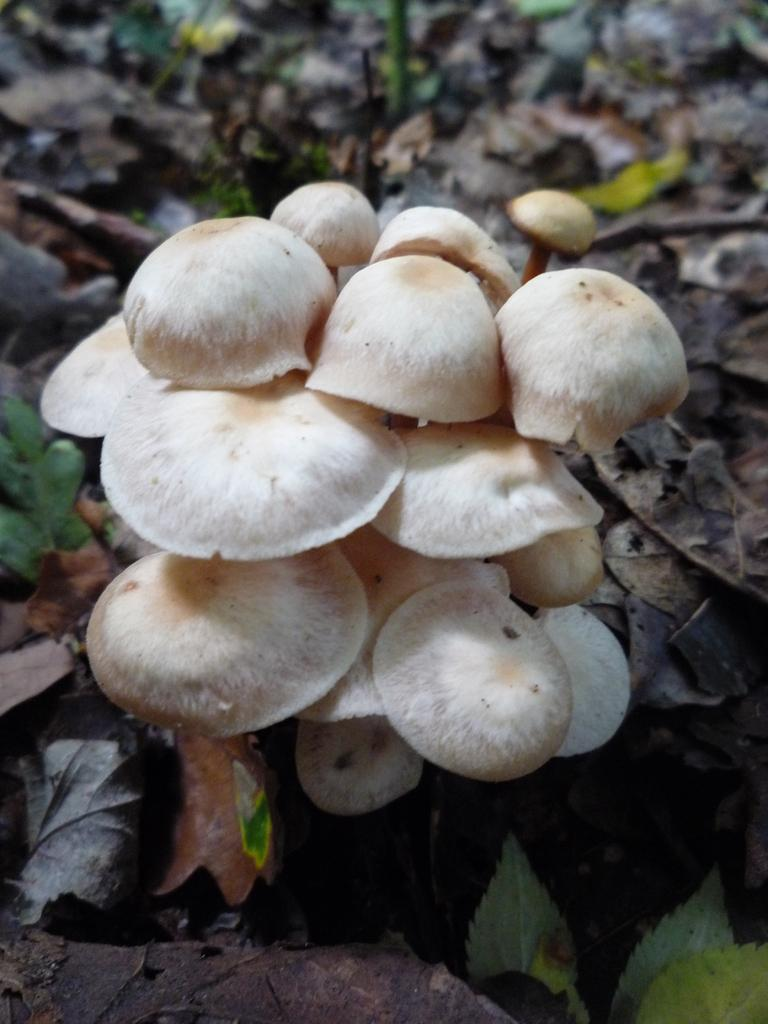What type of fungi can be seen in the image? There are mushrooms in the image. What can be found on the ground in the image? There are dry leaves on the ground in the image. Are there any spiders visible in the image? There is no mention of spiders in the provided facts, so we cannot determine their presence in the image. 